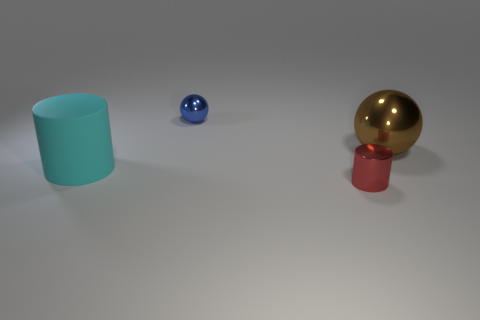Is there a ball that has the same material as the tiny cylinder? Yes, the ball on the right appears to have a reflective gold finish that is quite similar to the material of the tiny red cylinder in the foreground, suggesting they are made from materials with comparable properties, such as glossiness and reflectiveness. 